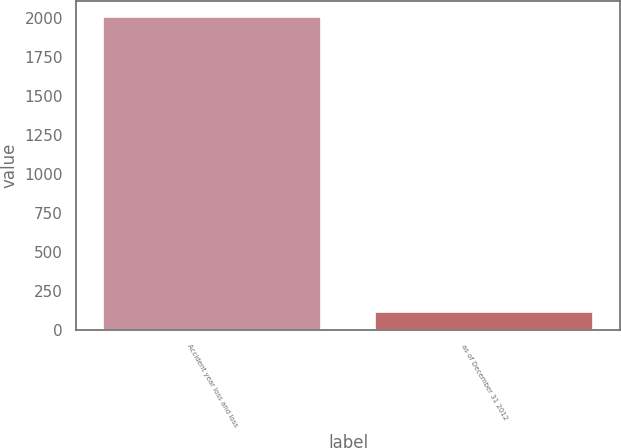<chart> <loc_0><loc_0><loc_500><loc_500><bar_chart><fcel>Accident year loss and loss<fcel>as of December 31 2012<nl><fcel>2011<fcel>117.2<nl></chart> 